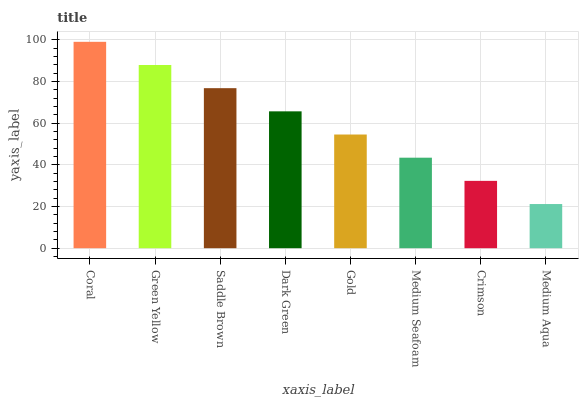Is Medium Aqua the minimum?
Answer yes or no. Yes. Is Coral the maximum?
Answer yes or no. Yes. Is Green Yellow the minimum?
Answer yes or no. No. Is Green Yellow the maximum?
Answer yes or no. No. Is Coral greater than Green Yellow?
Answer yes or no. Yes. Is Green Yellow less than Coral?
Answer yes or no. Yes. Is Green Yellow greater than Coral?
Answer yes or no. No. Is Coral less than Green Yellow?
Answer yes or no. No. Is Dark Green the high median?
Answer yes or no. Yes. Is Gold the low median?
Answer yes or no. Yes. Is Coral the high median?
Answer yes or no. No. Is Crimson the low median?
Answer yes or no. No. 